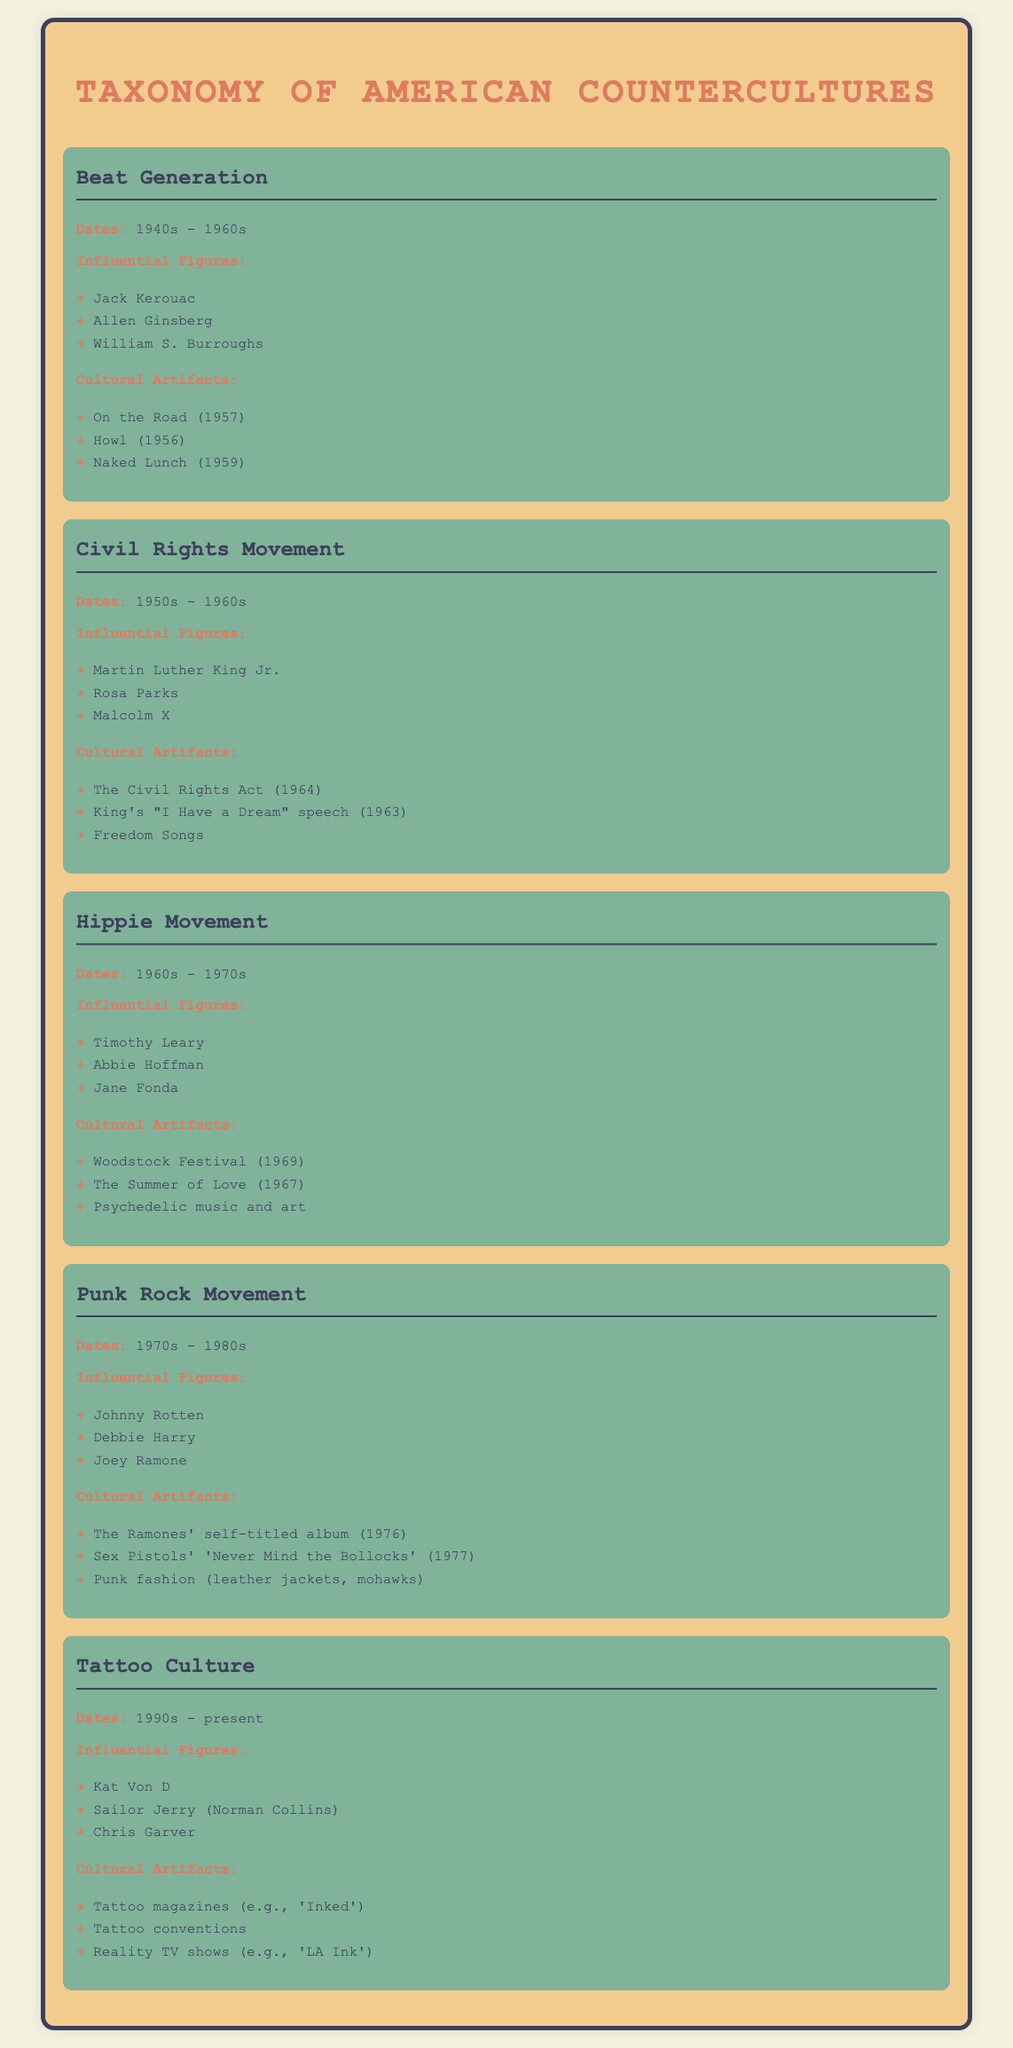What are the dates for the Beat Generation? The Beat Generation is dated from the 1940s to the 1960s.
Answer: 1940s - 1960s Who is an influential figure in the Civil Rights Movement? One influential figure mentioned in the Civil Rights Movement is Martin Luther King Jr.
Answer: Martin Luther King Jr What cultural artifact is associated with the Hippie Movement? A notable cultural artifact from the Hippie Movement is the Woodstock Festival, which took place in 1969.
Answer: Woodstock Festival (1969) During which decades did the Punk Rock Movement occur? The Punk Rock Movement occurred from the 1970s to the 1980s.
Answer: 1970s - 1980s What is a significant cultural artifact of Tattoo Culture? One significant cultural artifact of Tattoo Culture is tattoo magazines, such as 'Inked.'
Answer: Tattoo magazines (e.g., 'Inked') How many influential figures are listed in the Tattoo Culture section? There are three influential figures listed in the Tattoo Culture section.
Answer: Three What year did the Civil Rights Act take place? The Civil Rights Act was passed in 1964.
Answer: 1964 Which cultural movement is associated with the slogan "Make love, not war"? The Hippie Movement is typically associated with this slogan.
Answer: Hippie Movement 